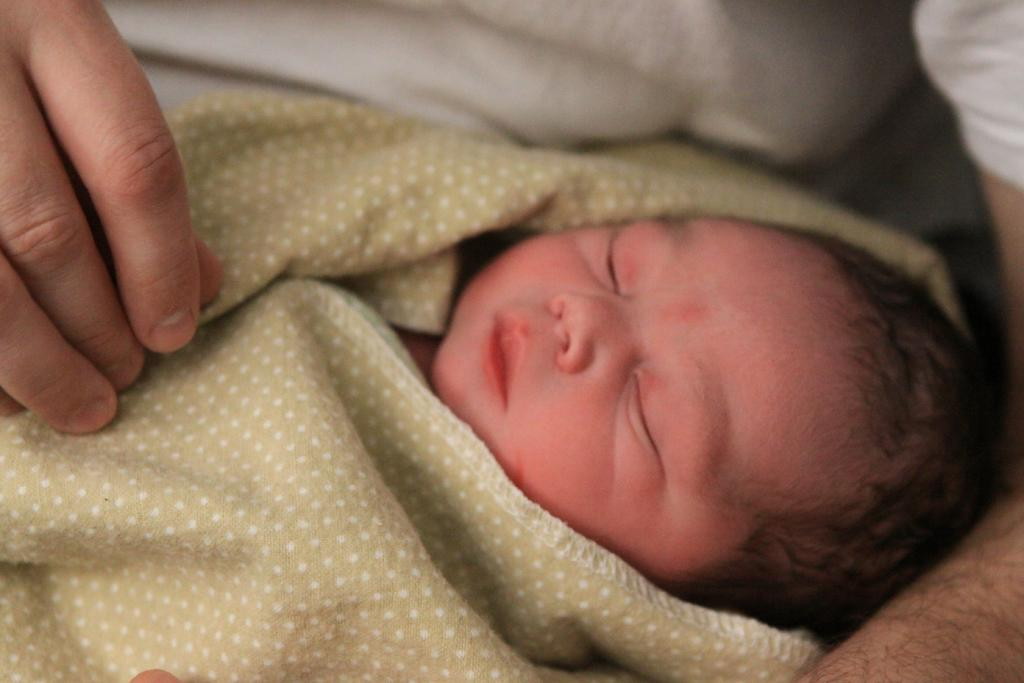What is the main subject of the image? There is a person in the image. What is the person doing in the image? The person is holding a baby. Is the person flying a kite in the image? No, there is no kite present in the image. The person is holding a baby, not flying a kite. 